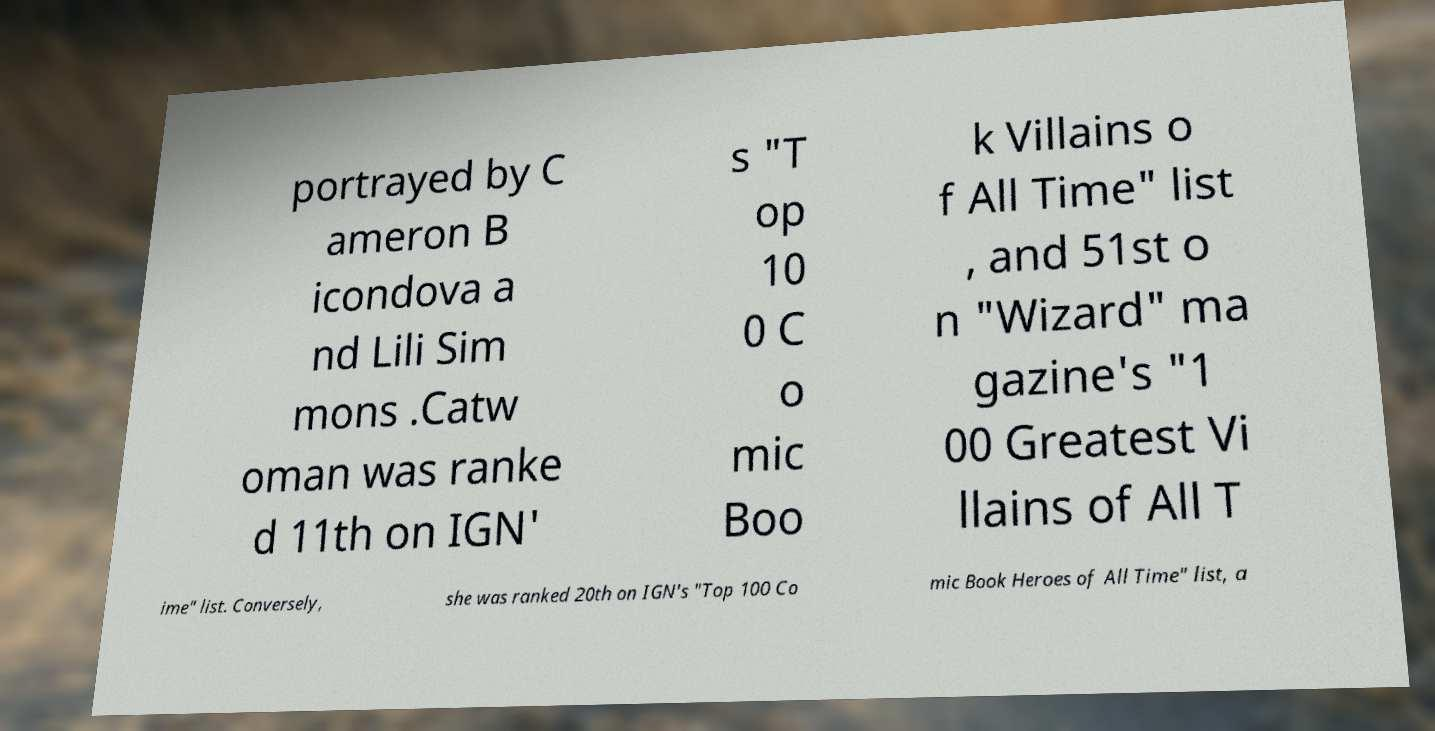Please read and relay the text visible in this image. What does it say? portrayed by C ameron B icondova a nd Lili Sim mons .Catw oman was ranke d 11th on IGN' s "T op 10 0 C o mic Boo k Villains o f All Time" list , and 51st o n "Wizard" ma gazine's "1 00 Greatest Vi llains of All T ime" list. Conversely, she was ranked 20th on IGN's "Top 100 Co mic Book Heroes of All Time" list, a 